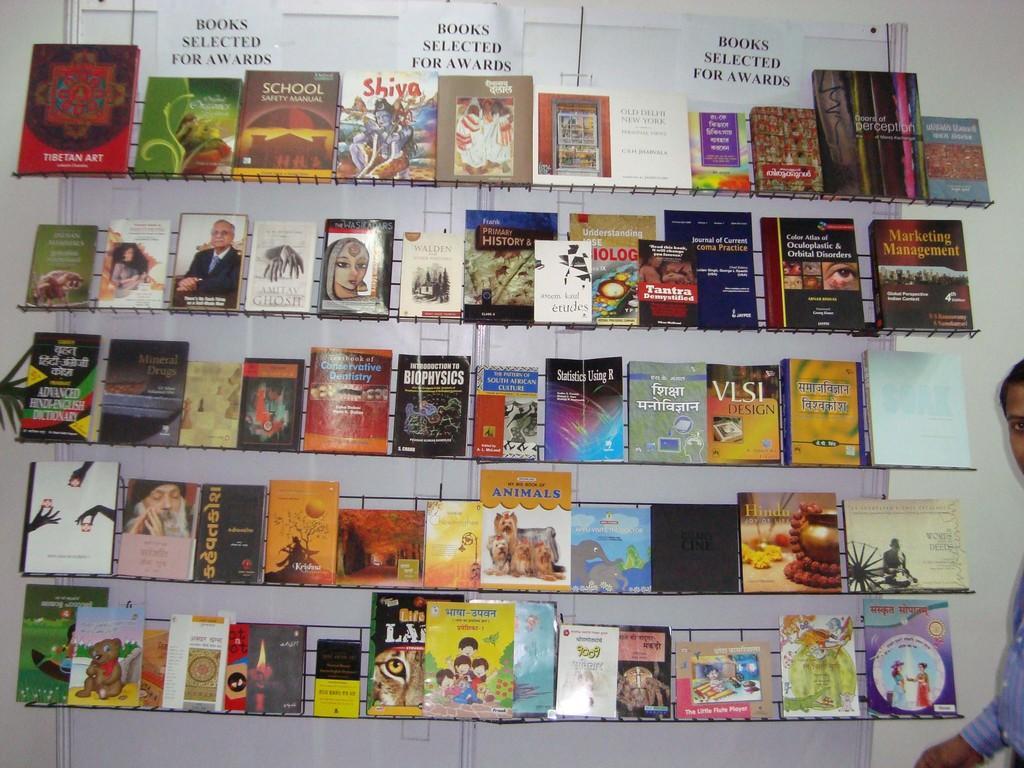In one or two sentences, can you explain what this image depicts? There are many books in the shelves. A person is standing on the right. There is a white wall at the back. 